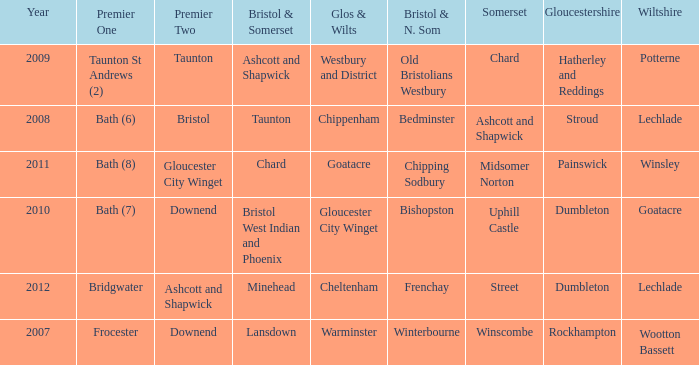What is the glos & wilts where the bristol & somerset is lansdown? Warminster. 